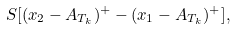<formula> <loc_0><loc_0><loc_500><loc_500>S [ ( x _ { 2 } - A _ { T _ { k } } ) ^ { + } - ( x _ { 1 } - A _ { T _ { k } } ) ^ { + } ] ,</formula> 